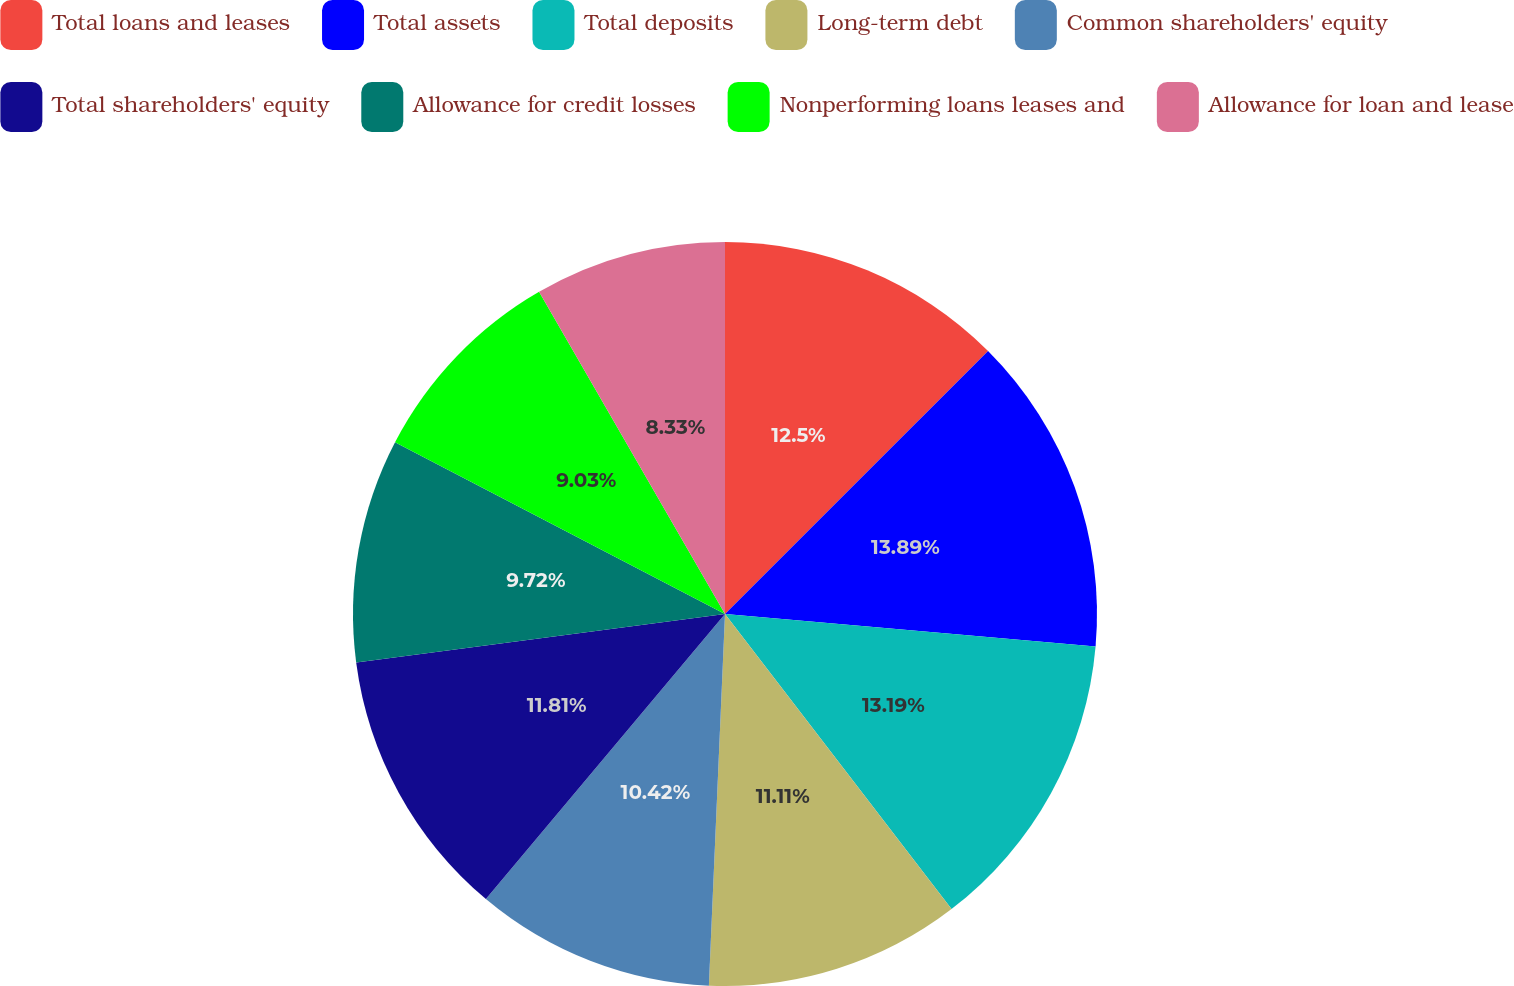Convert chart. <chart><loc_0><loc_0><loc_500><loc_500><pie_chart><fcel>Total loans and leases<fcel>Total assets<fcel>Total deposits<fcel>Long-term debt<fcel>Common shareholders' equity<fcel>Total shareholders' equity<fcel>Allowance for credit losses<fcel>Nonperforming loans leases and<fcel>Allowance for loan and lease<nl><fcel>12.5%<fcel>13.89%<fcel>13.19%<fcel>11.11%<fcel>10.42%<fcel>11.81%<fcel>9.72%<fcel>9.03%<fcel>8.33%<nl></chart> 